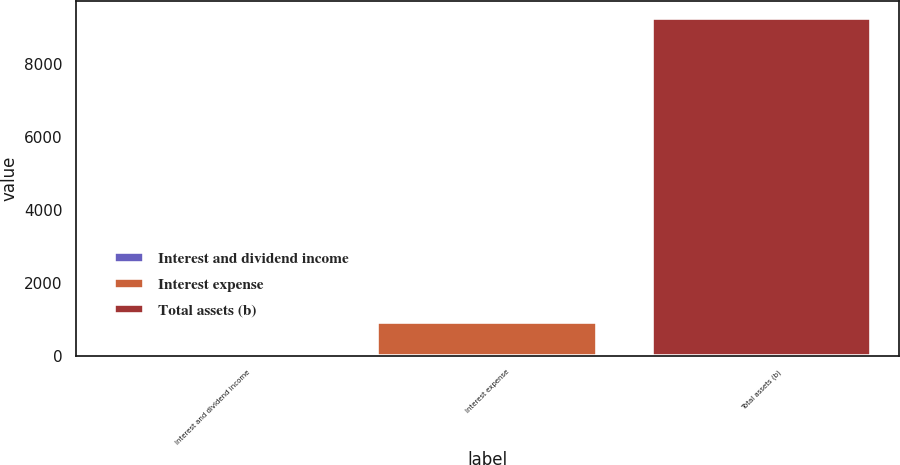<chart> <loc_0><loc_0><loc_500><loc_500><bar_chart><fcel>Interest and dividend income<fcel>Interest expense<fcel>Total assets (b)<nl><fcel>9<fcel>934.2<fcel>9261<nl></chart> 